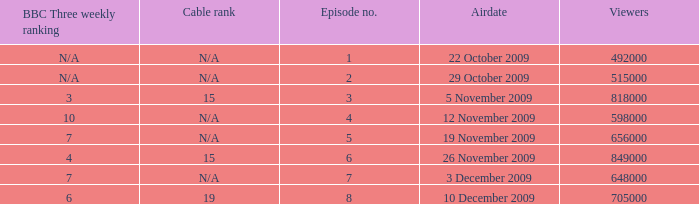Where where the bbc three weekly ranking for episode no. 5? 7.0. 